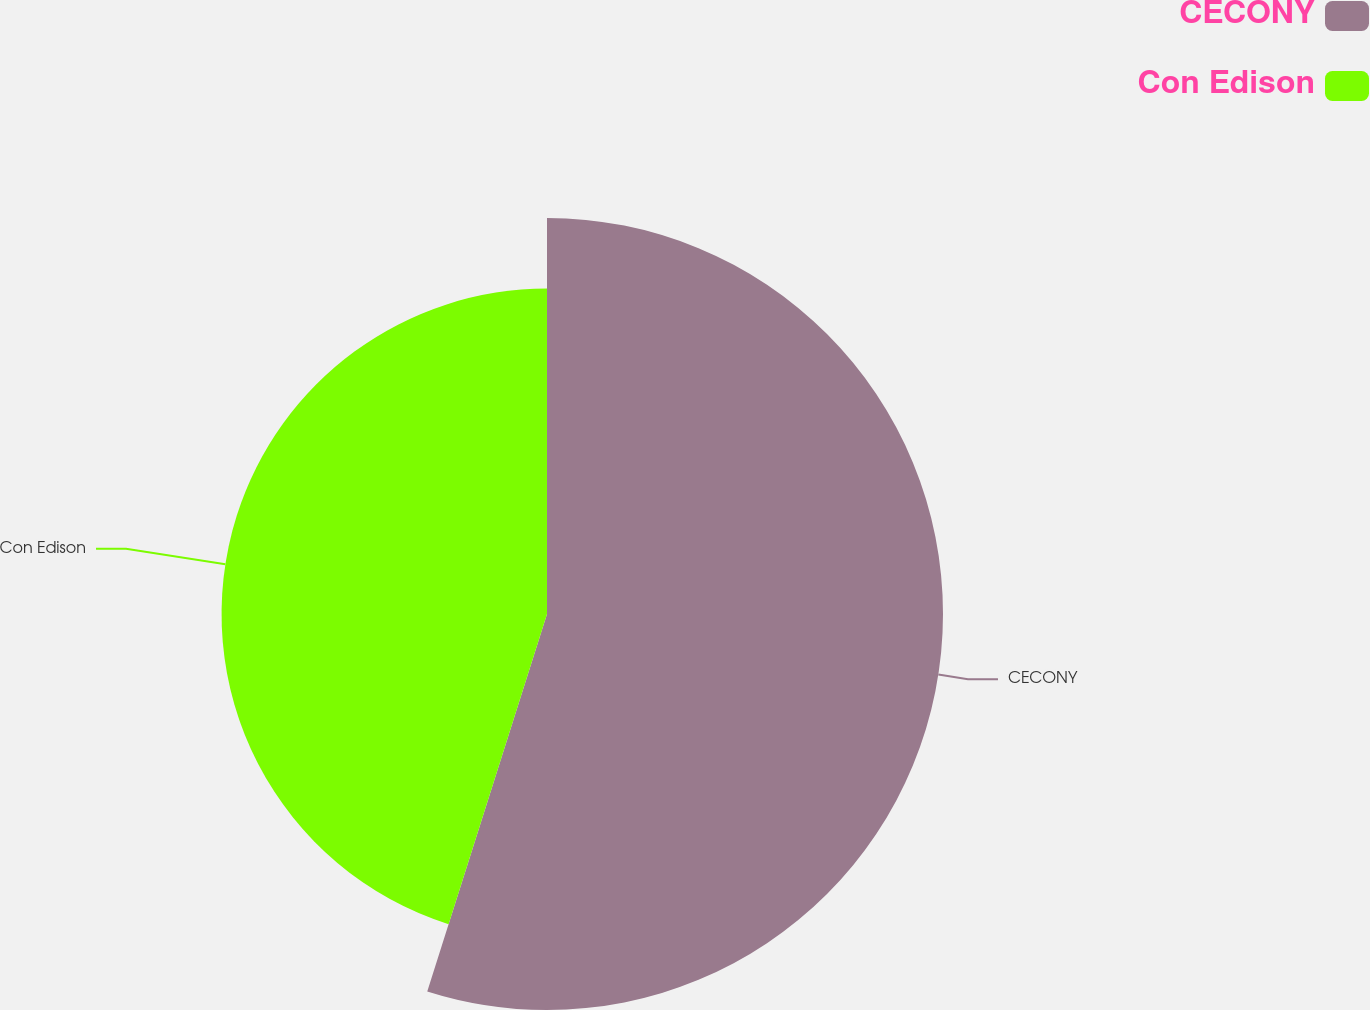Convert chart. <chart><loc_0><loc_0><loc_500><loc_500><pie_chart><fcel>CECONY<fcel>Con Edison<nl><fcel>54.89%<fcel>45.11%<nl></chart> 